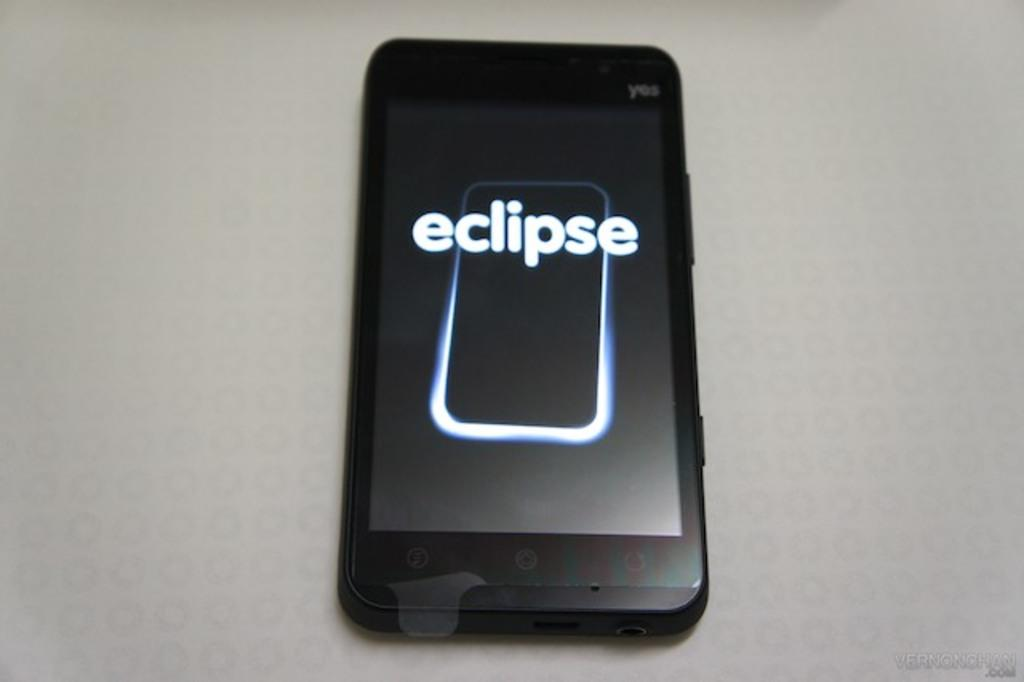<image>
Describe the image concisely. The phone on the table has an image with the word eclipse which shows how a solar eclipse may look like. 